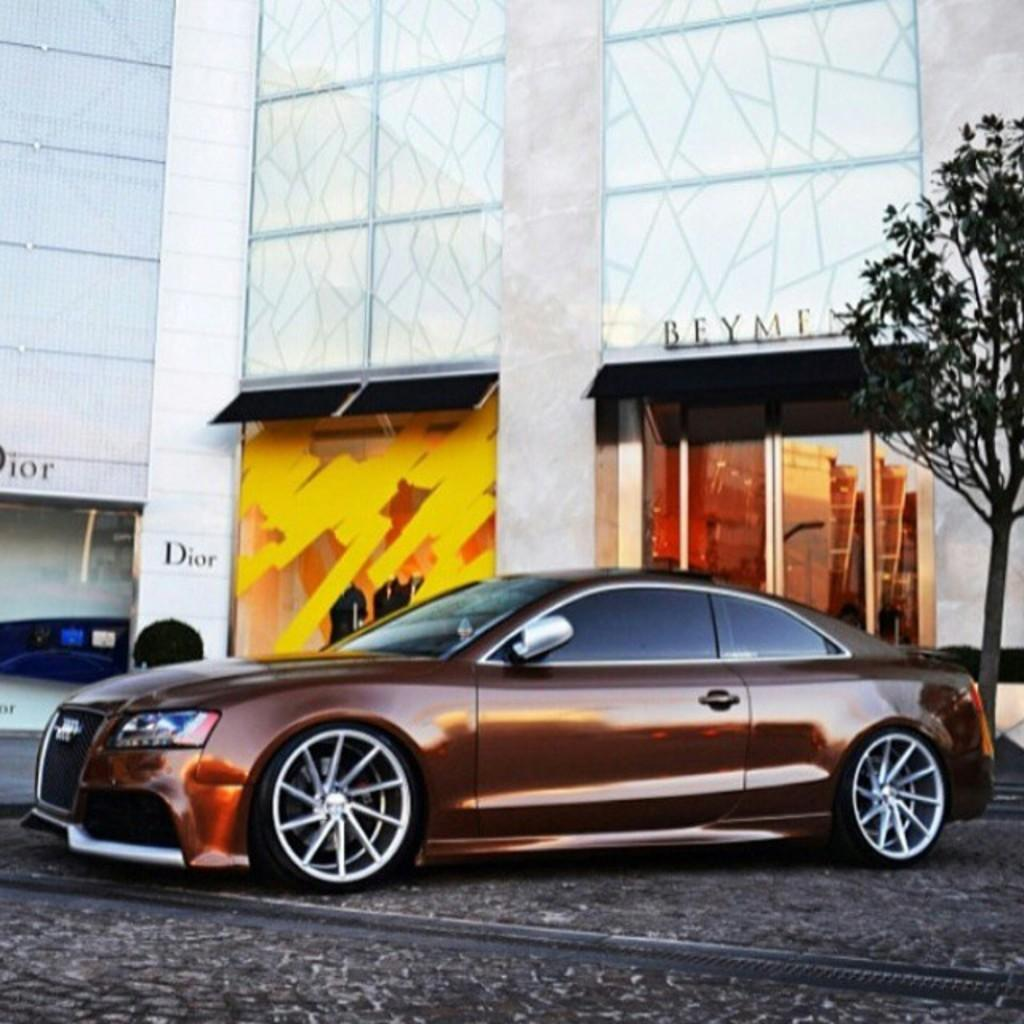What type of structures can be seen in the image? There are buildings in the image. What else is visible in the image besides the buildings? There is text visible in the image, as well as a glass door, a car, and a tree. What is the rate of the volleyball game happening in the image? There is no volleyball game present in the image, so it is not possible to determine the rate of any such game. 